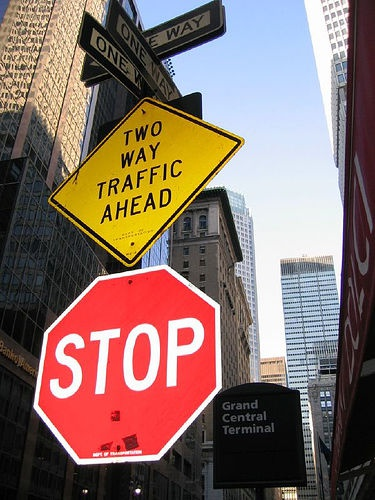Describe the objects in this image and their specific colors. I can see a stop sign in blue, red, and white tones in this image. 